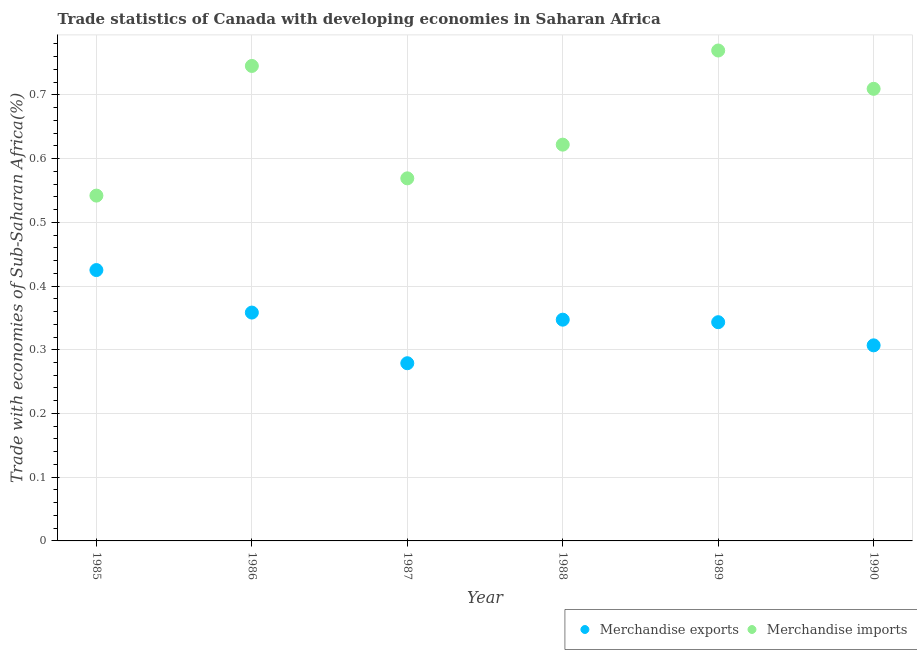How many different coloured dotlines are there?
Your answer should be compact. 2. What is the merchandise imports in 1990?
Offer a very short reply. 0.71. Across all years, what is the maximum merchandise exports?
Keep it short and to the point. 0.43. Across all years, what is the minimum merchandise imports?
Offer a terse response. 0.54. In which year was the merchandise exports minimum?
Offer a terse response. 1987. What is the total merchandise exports in the graph?
Offer a terse response. 2.06. What is the difference between the merchandise imports in 1989 and that in 1990?
Your answer should be compact. 0.06. What is the difference between the merchandise imports in 1989 and the merchandise exports in 1988?
Keep it short and to the point. 0.42. What is the average merchandise exports per year?
Offer a terse response. 0.34. In the year 1985, what is the difference between the merchandise imports and merchandise exports?
Offer a very short reply. 0.12. In how many years, is the merchandise imports greater than 0.24000000000000002 %?
Your answer should be compact. 6. What is the ratio of the merchandise exports in 1987 to that in 1990?
Provide a short and direct response. 0.91. What is the difference between the highest and the second highest merchandise imports?
Make the answer very short. 0.02. What is the difference between the highest and the lowest merchandise imports?
Keep it short and to the point. 0.23. Is the sum of the merchandise imports in 1985 and 1990 greater than the maximum merchandise exports across all years?
Give a very brief answer. Yes. Does the merchandise exports monotonically increase over the years?
Your answer should be very brief. No. How many dotlines are there?
Provide a succinct answer. 2. How many years are there in the graph?
Give a very brief answer. 6. What is the difference between two consecutive major ticks on the Y-axis?
Your answer should be very brief. 0.1. Are the values on the major ticks of Y-axis written in scientific E-notation?
Offer a terse response. No. Where does the legend appear in the graph?
Your answer should be very brief. Bottom right. How many legend labels are there?
Make the answer very short. 2. What is the title of the graph?
Offer a very short reply. Trade statistics of Canada with developing economies in Saharan Africa. What is the label or title of the X-axis?
Give a very brief answer. Year. What is the label or title of the Y-axis?
Make the answer very short. Trade with economies of Sub-Saharan Africa(%). What is the Trade with economies of Sub-Saharan Africa(%) in Merchandise exports in 1985?
Keep it short and to the point. 0.43. What is the Trade with economies of Sub-Saharan Africa(%) in Merchandise imports in 1985?
Your response must be concise. 0.54. What is the Trade with economies of Sub-Saharan Africa(%) in Merchandise exports in 1986?
Make the answer very short. 0.36. What is the Trade with economies of Sub-Saharan Africa(%) in Merchandise imports in 1986?
Your answer should be very brief. 0.75. What is the Trade with economies of Sub-Saharan Africa(%) of Merchandise exports in 1987?
Your answer should be compact. 0.28. What is the Trade with economies of Sub-Saharan Africa(%) in Merchandise imports in 1987?
Keep it short and to the point. 0.57. What is the Trade with economies of Sub-Saharan Africa(%) in Merchandise exports in 1988?
Ensure brevity in your answer.  0.35. What is the Trade with economies of Sub-Saharan Africa(%) of Merchandise imports in 1988?
Make the answer very short. 0.62. What is the Trade with economies of Sub-Saharan Africa(%) in Merchandise exports in 1989?
Keep it short and to the point. 0.34. What is the Trade with economies of Sub-Saharan Africa(%) in Merchandise imports in 1989?
Your response must be concise. 0.77. What is the Trade with economies of Sub-Saharan Africa(%) of Merchandise exports in 1990?
Provide a succinct answer. 0.31. What is the Trade with economies of Sub-Saharan Africa(%) in Merchandise imports in 1990?
Ensure brevity in your answer.  0.71. Across all years, what is the maximum Trade with economies of Sub-Saharan Africa(%) of Merchandise exports?
Offer a terse response. 0.43. Across all years, what is the maximum Trade with economies of Sub-Saharan Africa(%) in Merchandise imports?
Your answer should be very brief. 0.77. Across all years, what is the minimum Trade with economies of Sub-Saharan Africa(%) in Merchandise exports?
Offer a very short reply. 0.28. Across all years, what is the minimum Trade with economies of Sub-Saharan Africa(%) in Merchandise imports?
Your answer should be compact. 0.54. What is the total Trade with economies of Sub-Saharan Africa(%) of Merchandise exports in the graph?
Your answer should be compact. 2.06. What is the total Trade with economies of Sub-Saharan Africa(%) in Merchandise imports in the graph?
Provide a succinct answer. 3.96. What is the difference between the Trade with economies of Sub-Saharan Africa(%) of Merchandise exports in 1985 and that in 1986?
Give a very brief answer. 0.07. What is the difference between the Trade with economies of Sub-Saharan Africa(%) of Merchandise imports in 1985 and that in 1986?
Give a very brief answer. -0.2. What is the difference between the Trade with economies of Sub-Saharan Africa(%) in Merchandise exports in 1985 and that in 1987?
Give a very brief answer. 0.15. What is the difference between the Trade with economies of Sub-Saharan Africa(%) of Merchandise imports in 1985 and that in 1987?
Offer a terse response. -0.03. What is the difference between the Trade with economies of Sub-Saharan Africa(%) in Merchandise exports in 1985 and that in 1988?
Your response must be concise. 0.08. What is the difference between the Trade with economies of Sub-Saharan Africa(%) of Merchandise imports in 1985 and that in 1988?
Keep it short and to the point. -0.08. What is the difference between the Trade with economies of Sub-Saharan Africa(%) in Merchandise exports in 1985 and that in 1989?
Ensure brevity in your answer.  0.08. What is the difference between the Trade with economies of Sub-Saharan Africa(%) in Merchandise imports in 1985 and that in 1989?
Your answer should be very brief. -0.23. What is the difference between the Trade with economies of Sub-Saharan Africa(%) of Merchandise exports in 1985 and that in 1990?
Your response must be concise. 0.12. What is the difference between the Trade with economies of Sub-Saharan Africa(%) in Merchandise imports in 1985 and that in 1990?
Give a very brief answer. -0.17. What is the difference between the Trade with economies of Sub-Saharan Africa(%) in Merchandise exports in 1986 and that in 1987?
Your answer should be very brief. 0.08. What is the difference between the Trade with economies of Sub-Saharan Africa(%) of Merchandise imports in 1986 and that in 1987?
Offer a very short reply. 0.18. What is the difference between the Trade with economies of Sub-Saharan Africa(%) of Merchandise exports in 1986 and that in 1988?
Your response must be concise. 0.01. What is the difference between the Trade with economies of Sub-Saharan Africa(%) of Merchandise imports in 1986 and that in 1988?
Your response must be concise. 0.12. What is the difference between the Trade with economies of Sub-Saharan Africa(%) in Merchandise exports in 1986 and that in 1989?
Keep it short and to the point. 0.02. What is the difference between the Trade with economies of Sub-Saharan Africa(%) of Merchandise imports in 1986 and that in 1989?
Your answer should be compact. -0.02. What is the difference between the Trade with economies of Sub-Saharan Africa(%) of Merchandise exports in 1986 and that in 1990?
Provide a succinct answer. 0.05. What is the difference between the Trade with economies of Sub-Saharan Africa(%) in Merchandise imports in 1986 and that in 1990?
Provide a succinct answer. 0.04. What is the difference between the Trade with economies of Sub-Saharan Africa(%) in Merchandise exports in 1987 and that in 1988?
Provide a short and direct response. -0.07. What is the difference between the Trade with economies of Sub-Saharan Africa(%) of Merchandise imports in 1987 and that in 1988?
Ensure brevity in your answer.  -0.05. What is the difference between the Trade with economies of Sub-Saharan Africa(%) in Merchandise exports in 1987 and that in 1989?
Keep it short and to the point. -0.06. What is the difference between the Trade with economies of Sub-Saharan Africa(%) in Merchandise imports in 1987 and that in 1989?
Ensure brevity in your answer.  -0.2. What is the difference between the Trade with economies of Sub-Saharan Africa(%) of Merchandise exports in 1987 and that in 1990?
Offer a terse response. -0.03. What is the difference between the Trade with economies of Sub-Saharan Africa(%) in Merchandise imports in 1987 and that in 1990?
Your response must be concise. -0.14. What is the difference between the Trade with economies of Sub-Saharan Africa(%) of Merchandise exports in 1988 and that in 1989?
Offer a very short reply. 0. What is the difference between the Trade with economies of Sub-Saharan Africa(%) in Merchandise imports in 1988 and that in 1989?
Keep it short and to the point. -0.15. What is the difference between the Trade with economies of Sub-Saharan Africa(%) of Merchandise exports in 1988 and that in 1990?
Ensure brevity in your answer.  0.04. What is the difference between the Trade with economies of Sub-Saharan Africa(%) of Merchandise imports in 1988 and that in 1990?
Give a very brief answer. -0.09. What is the difference between the Trade with economies of Sub-Saharan Africa(%) in Merchandise exports in 1989 and that in 1990?
Your answer should be very brief. 0.04. What is the difference between the Trade with economies of Sub-Saharan Africa(%) in Merchandise imports in 1989 and that in 1990?
Your answer should be compact. 0.06. What is the difference between the Trade with economies of Sub-Saharan Africa(%) in Merchandise exports in 1985 and the Trade with economies of Sub-Saharan Africa(%) in Merchandise imports in 1986?
Your answer should be compact. -0.32. What is the difference between the Trade with economies of Sub-Saharan Africa(%) of Merchandise exports in 1985 and the Trade with economies of Sub-Saharan Africa(%) of Merchandise imports in 1987?
Offer a terse response. -0.14. What is the difference between the Trade with economies of Sub-Saharan Africa(%) in Merchandise exports in 1985 and the Trade with economies of Sub-Saharan Africa(%) in Merchandise imports in 1988?
Ensure brevity in your answer.  -0.2. What is the difference between the Trade with economies of Sub-Saharan Africa(%) of Merchandise exports in 1985 and the Trade with economies of Sub-Saharan Africa(%) of Merchandise imports in 1989?
Your response must be concise. -0.34. What is the difference between the Trade with economies of Sub-Saharan Africa(%) in Merchandise exports in 1985 and the Trade with economies of Sub-Saharan Africa(%) in Merchandise imports in 1990?
Keep it short and to the point. -0.28. What is the difference between the Trade with economies of Sub-Saharan Africa(%) in Merchandise exports in 1986 and the Trade with economies of Sub-Saharan Africa(%) in Merchandise imports in 1987?
Ensure brevity in your answer.  -0.21. What is the difference between the Trade with economies of Sub-Saharan Africa(%) in Merchandise exports in 1986 and the Trade with economies of Sub-Saharan Africa(%) in Merchandise imports in 1988?
Keep it short and to the point. -0.26. What is the difference between the Trade with economies of Sub-Saharan Africa(%) of Merchandise exports in 1986 and the Trade with economies of Sub-Saharan Africa(%) of Merchandise imports in 1989?
Offer a very short reply. -0.41. What is the difference between the Trade with economies of Sub-Saharan Africa(%) of Merchandise exports in 1986 and the Trade with economies of Sub-Saharan Africa(%) of Merchandise imports in 1990?
Ensure brevity in your answer.  -0.35. What is the difference between the Trade with economies of Sub-Saharan Africa(%) of Merchandise exports in 1987 and the Trade with economies of Sub-Saharan Africa(%) of Merchandise imports in 1988?
Offer a very short reply. -0.34. What is the difference between the Trade with economies of Sub-Saharan Africa(%) in Merchandise exports in 1987 and the Trade with economies of Sub-Saharan Africa(%) in Merchandise imports in 1989?
Your answer should be very brief. -0.49. What is the difference between the Trade with economies of Sub-Saharan Africa(%) of Merchandise exports in 1987 and the Trade with economies of Sub-Saharan Africa(%) of Merchandise imports in 1990?
Your answer should be very brief. -0.43. What is the difference between the Trade with economies of Sub-Saharan Africa(%) of Merchandise exports in 1988 and the Trade with economies of Sub-Saharan Africa(%) of Merchandise imports in 1989?
Your answer should be very brief. -0.42. What is the difference between the Trade with economies of Sub-Saharan Africa(%) in Merchandise exports in 1988 and the Trade with economies of Sub-Saharan Africa(%) in Merchandise imports in 1990?
Provide a short and direct response. -0.36. What is the difference between the Trade with economies of Sub-Saharan Africa(%) of Merchandise exports in 1989 and the Trade with economies of Sub-Saharan Africa(%) of Merchandise imports in 1990?
Give a very brief answer. -0.37. What is the average Trade with economies of Sub-Saharan Africa(%) in Merchandise exports per year?
Offer a terse response. 0.34. What is the average Trade with economies of Sub-Saharan Africa(%) of Merchandise imports per year?
Offer a terse response. 0.66. In the year 1985, what is the difference between the Trade with economies of Sub-Saharan Africa(%) of Merchandise exports and Trade with economies of Sub-Saharan Africa(%) of Merchandise imports?
Keep it short and to the point. -0.12. In the year 1986, what is the difference between the Trade with economies of Sub-Saharan Africa(%) in Merchandise exports and Trade with economies of Sub-Saharan Africa(%) in Merchandise imports?
Your response must be concise. -0.39. In the year 1987, what is the difference between the Trade with economies of Sub-Saharan Africa(%) of Merchandise exports and Trade with economies of Sub-Saharan Africa(%) of Merchandise imports?
Offer a very short reply. -0.29. In the year 1988, what is the difference between the Trade with economies of Sub-Saharan Africa(%) in Merchandise exports and Trade with economies of Sub-Saharan Africa(%) in Merchandise imports?
Give a very brief answer. -0.27. In the year 1989, what is the difference between the Trade with economies of Sub-Saharan Africa(%) in Merchandise exports and Trade with economies of Sub-Saharan Africa(%) in Merchandise imports?
Offer a terse response. -0.43. In the year 1990, what is the difference between the Trade with economies of Sub-Saharan Africa(%) of Merchandise exports and Trade with economies of Sub-Saharan Africa(%) of Merchandise imports?
Make the answer very short. -0.4. What is the ratio of the Trade with economies of Sub-Saharan Africa(%) of Merchandise exports in 1985 to that in 1986?
Offer a terse response. 1.19. What is the ratio of the Trade with economies of Sub-Saharan Africa(%) of Merchandise imports in 1985 to that in 1986?
Your response must be concise. 0.73. What is the ratio of the Trade with economies of Sub-Saharan Africa(%) of Merchandise exports in 1985 to that in 1987?
Your answer should be compact. 1.52. What is the ratio of the Trade with economies of Sub-Saharan Africa(%) of Merchandise imports in 1985 to that in 1987?
Make the answer very short. 0.95. What is the ratio of the Trade with economies of Sub-Saharan Africa(%) in Merchandise exports in 1985 to that in 1988?
Provide a succinct answer. 1.22. What is the ratio of the Trade with economies of Sub-Saharan Africa(%) of Merchandise imports in 1985 to that in 1988?
Offer a terse response. 0.87. What is the ratio of the Trade with economies of Sub-Saharan Africa(%) in Merchandise exports in 1985 to that in 1989?
Give a very brief answer. 1.24. What is the ratio of the Trade with economies of Sub-Saharan Africa(%) in Merchandise imports in 1985 to that in 1989?
Provide a short and direct response. 0.7. What is the ratio of the Trade with economies of Sub-Saharan Africa(%) of Merchandise exports in 1985 to that in 1990?
Your answer should be compact. 1.38. What is the ratio of the Trade with economies of Sub-Saharan Africa(%) of Merchandise imports in 1985 to that in 1990?
Make the answer very short. 0.76. What is the ratio of the Trade with economies of Sub-Saharan Africa(%) of Merchandise exports in 1986 to that in 1987?
Offer a terse response. 1.29. What is the ratio of the Trade with economies of Sub-Saharan Africa(%) of Merchandise imports in 1986 to that in 1987?
Provide a short and direct response. 1.31. What is the ratio of the Trade with economies of Sub-Saharan Africa(%) in Merchandise exports in 1986 to that in 1988?
Provide a short and direct response. 1.03. What is the ratio of the Trade with economies of Sub-Saharan Africa(%) of Merchandise imports in 1986 to that in 1988?
Make the answer very short. 1.2. What is the ratio of the Trade with economies of Sub-Saharan Africa(%) of Merchandise exports in 1986 to that in 1989?
Provide a short and direct response. 1.04. What is the ratio of the Trade with economies of Sub-Saharan Africa(%) in Merchandise imports in 1986 to that in 1989?
Keep it short and to the point. 0.97. What is the ratio of the Trade with economies of Sub-Saharan Africa(%) in Merchandise exports in 1986 to that in 1990?
Your response must be concise. 1.17. What is the ratio of the Trade with economies of Sub-Saharan Africa(%) of Merchandise imports in 1986 to that in 1990?
Offer a terse response. 1.05. What is the ratio of the Trade with economies of Sub-Saharan Africa(%) of Merchandise exports in 1987 to that in 1988?
Keep it short and to the point. 0.8. What is the ratio of the Trade with economies of Sub-Saharan Africa(%) in Merchandise imports in 1987 to that in 1988?
Your answer should be compact. 0.92. What is the ratio of the Trade with economies of Sub-Saharan Africa(%) in Merchandise exports in 1987 to that in 1989?
Offer a very short reply. 0.81. What is the ratio of the Trade with economies of Sub-Saharan Africa(%) in Merchandise imports in 1987 to that in 1989?
Your answer should be compact. 0.74. What is the ratio of the Trade with economies of Sub-Saharan Africa(%) in Merchandise exports in 1987 to that in 1990?
Offer a very short reply. 0.91. What is the ratio of the Trade with economies of Sub-Saharan Africa(%) in Merchandise imports in 1987 to that in 1990?
Provide a short and direct response. 0.8. What is the ratio of the Trade with economies of Sub-Saharan Africa(%) of Merchandise exports in 1988 to that in 1989?
Your response must be concise. 1.01. What is the ratio of the Trade with economies of Sub-Saharan Africa(%) in Merchandise imports in 1988 to that in 1989?
Provide a succinct answer. 0.81. What is the ratio of the Trade with economies of Sub-Saharan Africa(%) in Merchandise exports in 1988 to that in 1990?
Keep it short and to the point. 1.13. What is the ratio of the Trade with economies of Sub-Saharan Africa(%) of Merchandise imports in 1988 to that in 1990?
Your answer should be very brief. 0.88. What is the ratio of the Trade with economies of Sub-Saharan Africa(%) in Merchandise exports in 1989 to that in 1990?
Give a very brief answer. 1.12. What is the ratio of the Trade with economies of Sub-Saharan Africa(%) in Merchandise imports in 1989 to that in 1990?
Offer a terse response. 1.08. What is the difference between the highest and the second highest Trade with economies of Sub-Saharan Africa(%) of Merchandise exports?
Provide a succinct answer. 0.07. What is the difference between the highest and the second highest Trade with economies of Sub-Saharan Africa(%) in Merchandise imports?
Provide a succinct answer. 0.02. What is the difference between the highest and the lowest Trade with economies of Sub-Saharan Africa(%) of Merchandise exports?
Keep it short and to the point. 0.15. What is the difference between the highest and the lowest Trade with economies of Sub-Saharan Africa(%) of Merchandise imports?
Give a very brief answer. 0.23. 